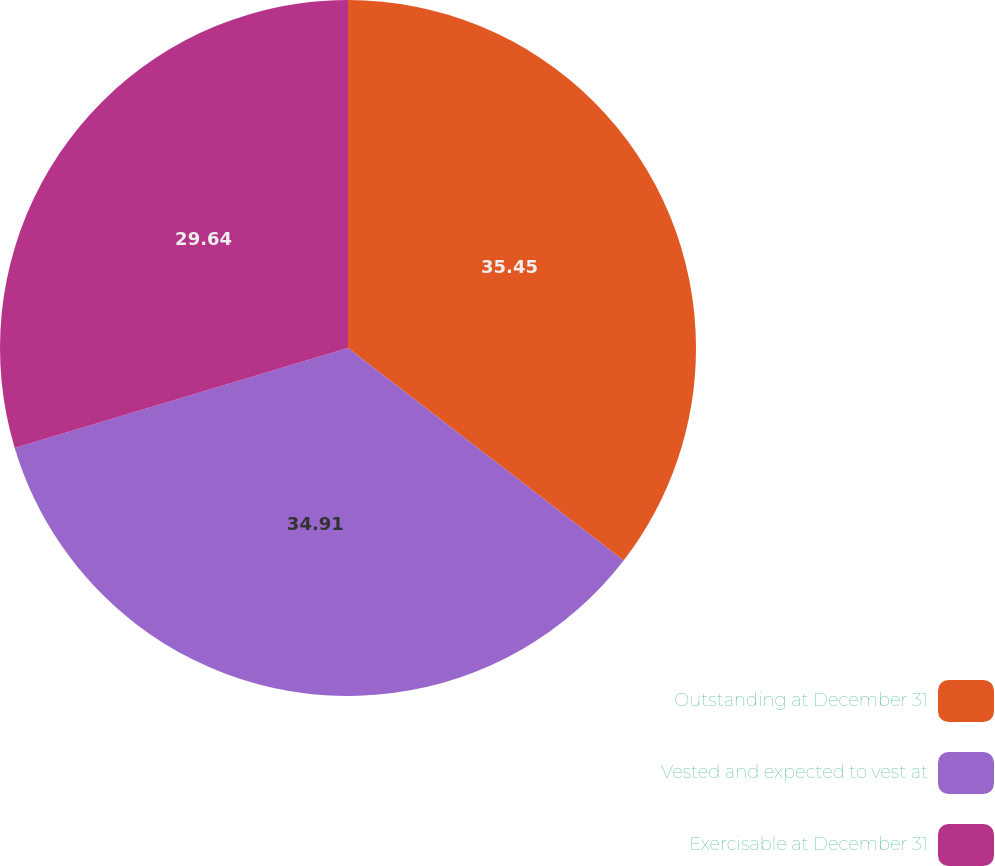Convert chart to OTSL. <chart><loc_0><loc_0><loc_500><loc_500><pie_chart><fcel>Outstanding at December 31<fcel>Vested and expected to vest at<fcel>Exercisable at December 31<nl><fcel>35.45%<fcel>34.91%<fcel>29.64%<nl></chart> 